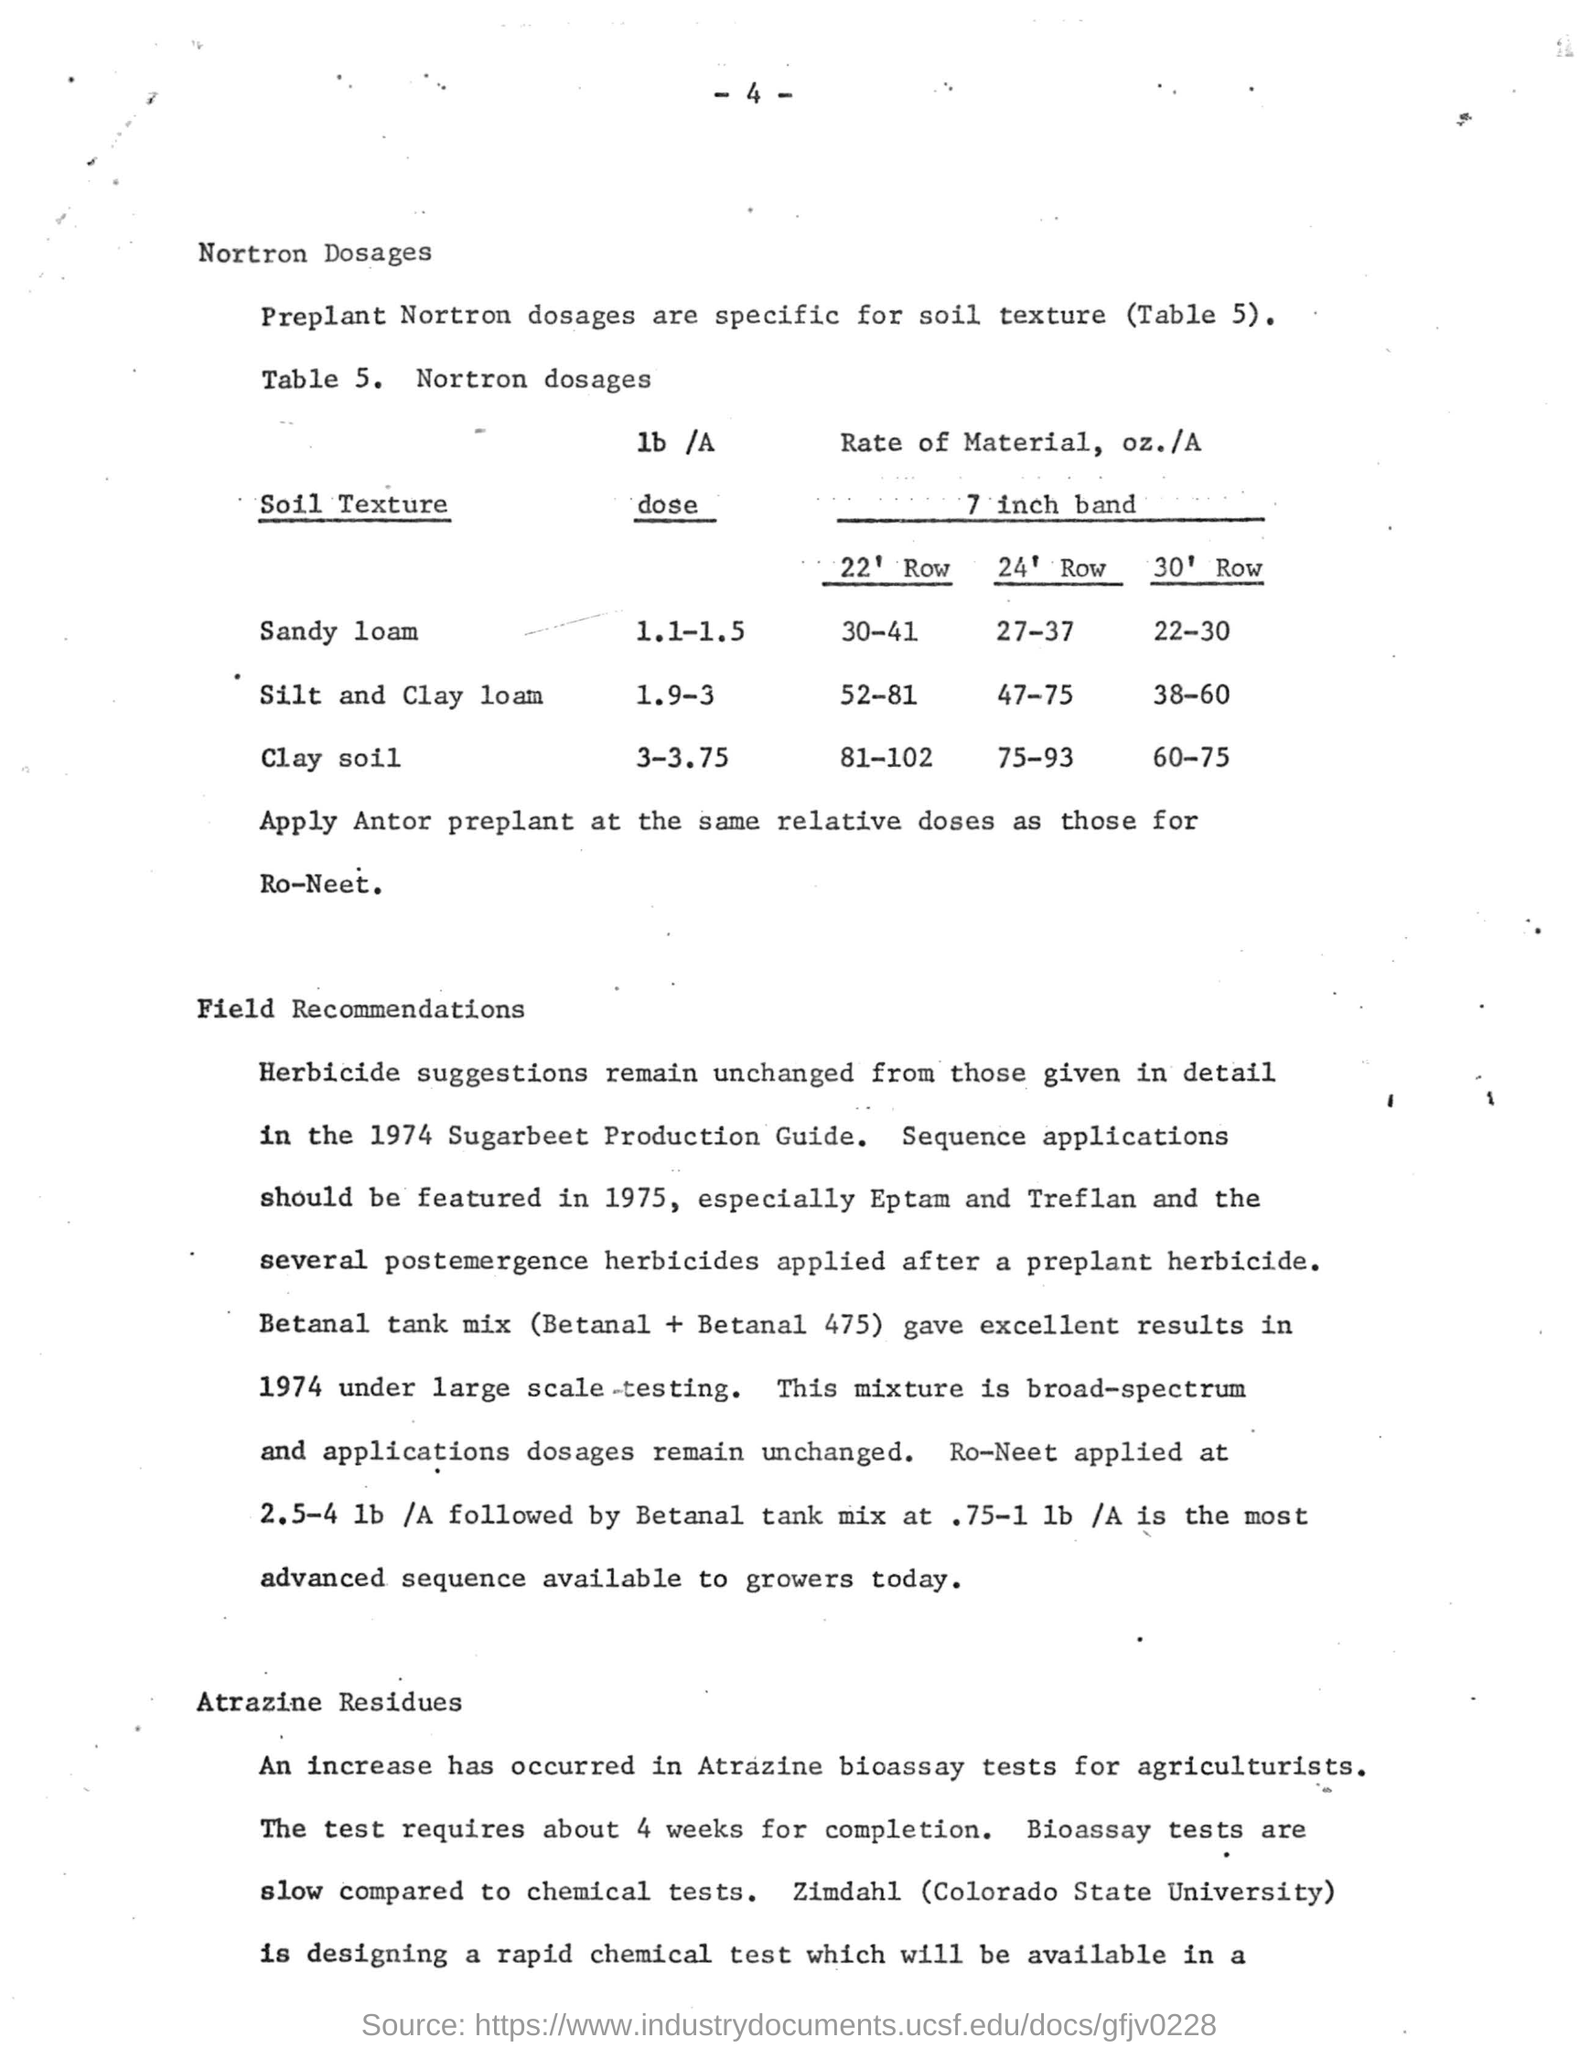What is the Nortron dose(lb/A) for Sandy loam soil?
Ensure brevity in your answer.  1.1-1.5. What is the Nortron dose(lb/A) for Clay soil?
Offer a terse response. 3-3.75. What is the Rate of Material(oz./A) for 22' Row in Silt and Clay loam?
Give a very brief answer. 52-81. What is the Rate of Material(oz./A) for 30' Row in Clay soil?
Provide a short and direct response. 60-75. Which soil texture gets Nortron dosage(lb/A) of 1.9-3 ?
Your answer should be compact. Silt and Clay loam. 